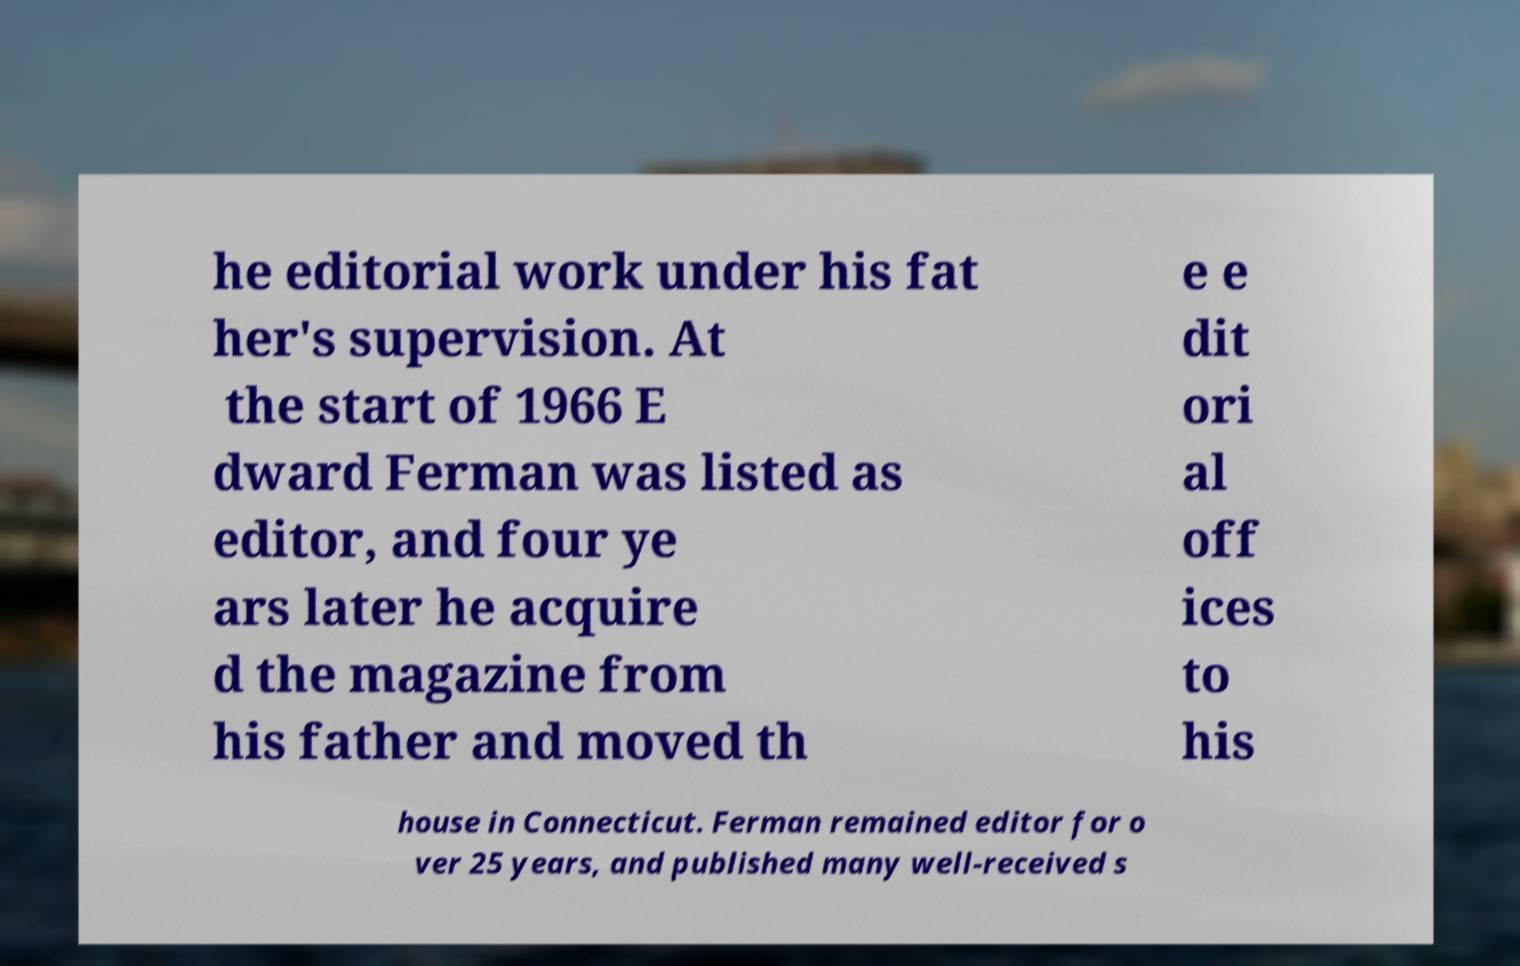Can you accurately transcribe the text from the provided image for me? he editorial work under his fat her's supervision. At the start of 1966 E dward Ferman was listed as editor, and four ye ars later he acquire d the magazine from his father and moved th e e dit ori al off ices to his house in Connecticut. Ferman remained editor for o ver 25 years, and published many well-received s 